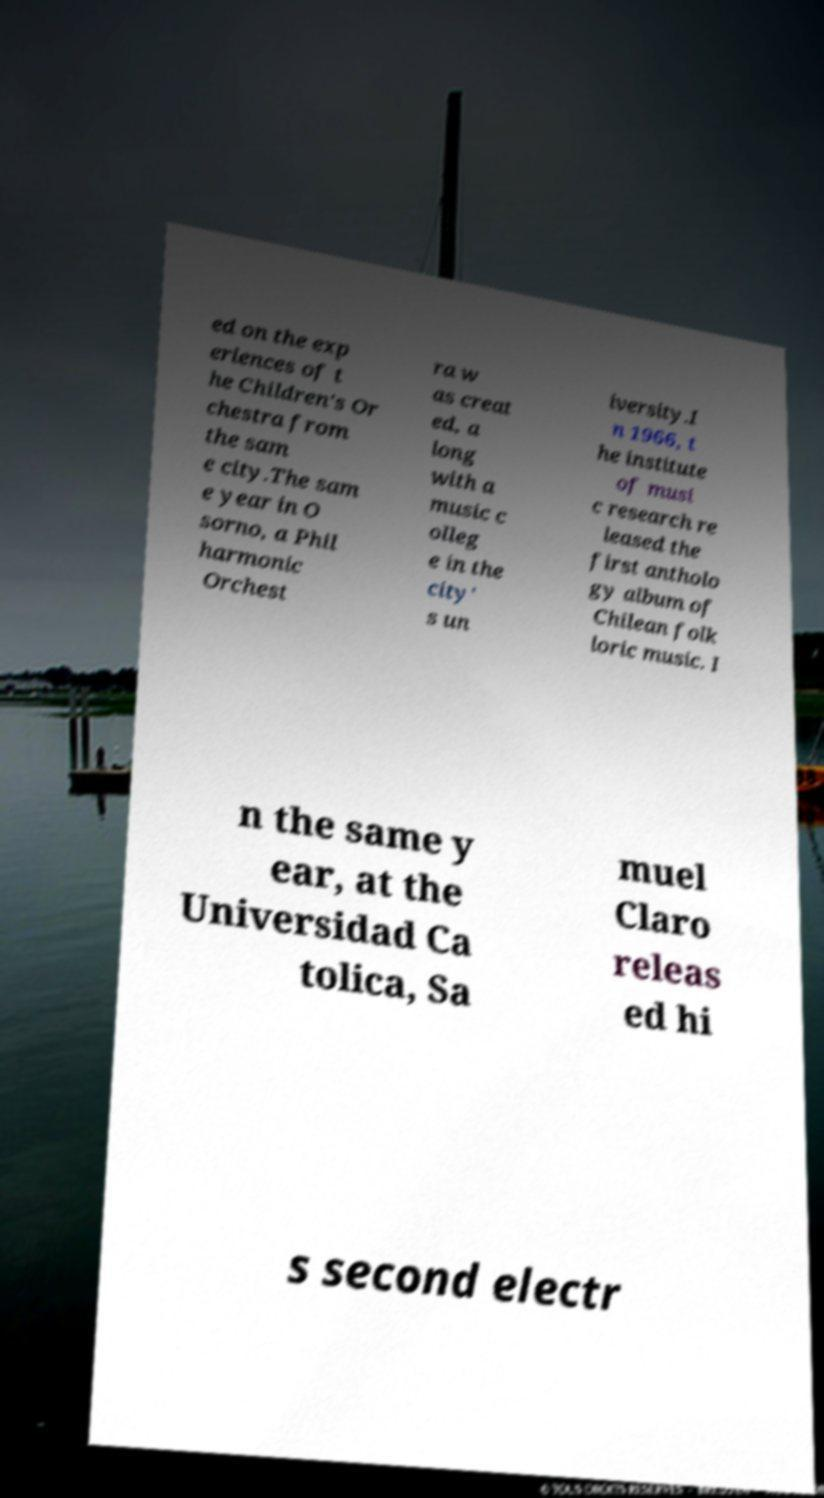Could you extract and type out the text from this image? ed on the exp eriences of t he Children's Or chestra from the sam e city.The sam e year in O sorno, a Phil harmonic Orchest ra w as creat ed, a long with a music c olleg e in the city' s un iversity.I n 1966, t he institute of musi c research re leased the first antholo gy album of Chilean folk loric music. I n the same y ear, at the Universidad Ca tolica, Sa muel Claro releas ed hi s second electr 